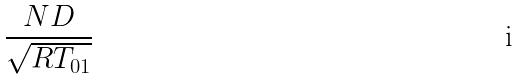<formula> <loc_0><loc_0><loc_500><loc_500>\frac { N D } { \sqrt { R T _ { 0 1 } } }</formula> 